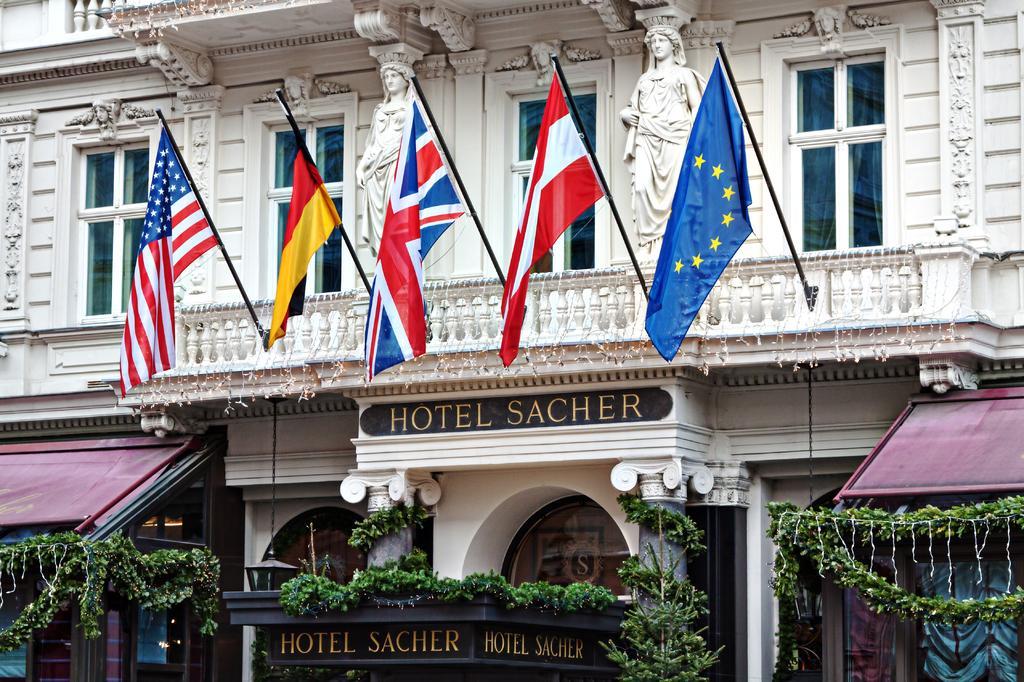How would you summarize this image in a sentence or two? In the center of the image we can see flags to the building. At the bottom of the image we can see plants, tents and name board. 